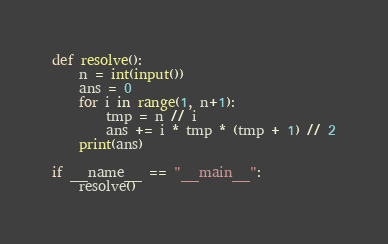<code> <loc_0><loc_0><loc_500><loc_500><_Python_>
def resolve():
    n = int(input())
    ans = 0
    for i in range(1, n+1):
        tmp = n // i
        ans += i * tmp * (tmp + 1) // 2
    print(ans)

if __name__ == "__main__":
    resolve()
</code> 